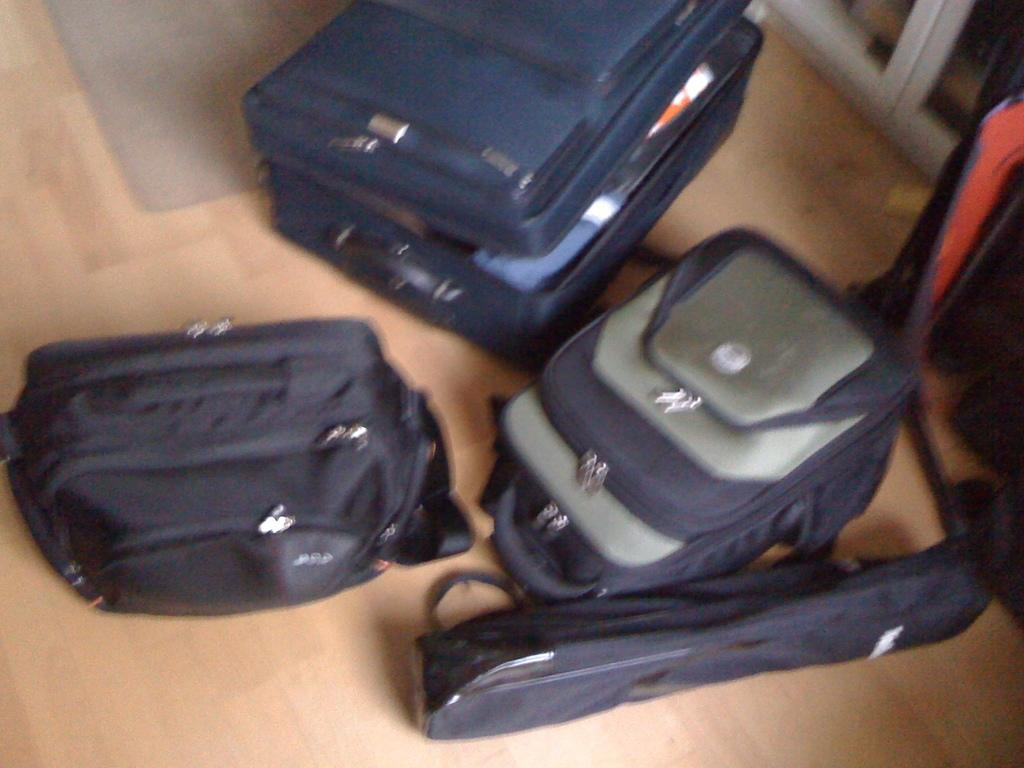What type of bags can be seen in the image? There are backpacks, luggage bags, and a carrying bag in the image. How many different colors are present on the backpacks? The backpacks have different colors. How many different colors are present on the luggage bags? The luggage bags have different colors. Can you describe the carrying bag in the image? There is a carrying bag in the image. What type of cloth is used to make the army uniforms in the image? There is no mention of army uniforms or cloth in the image; it only features bags of different colors and types. 